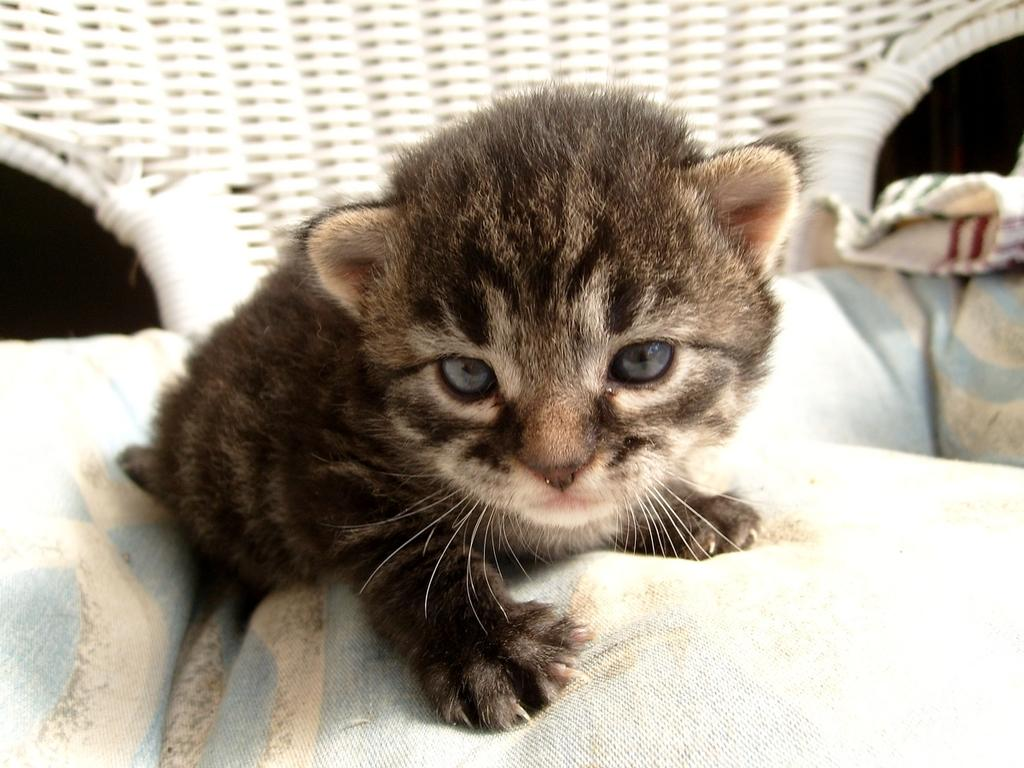What is the main subject of the picture? The main subject of the picture is a kitten. Where is the kitten located in the picture? The kitten is on a cloth. What else can be seen in the background of the picture? There appears to be a chair in the background of the picture. What type of toothbrush is the kitten using in the picture? There is no toothbrush present in the image, and the kitten is not using any object in the picture. 